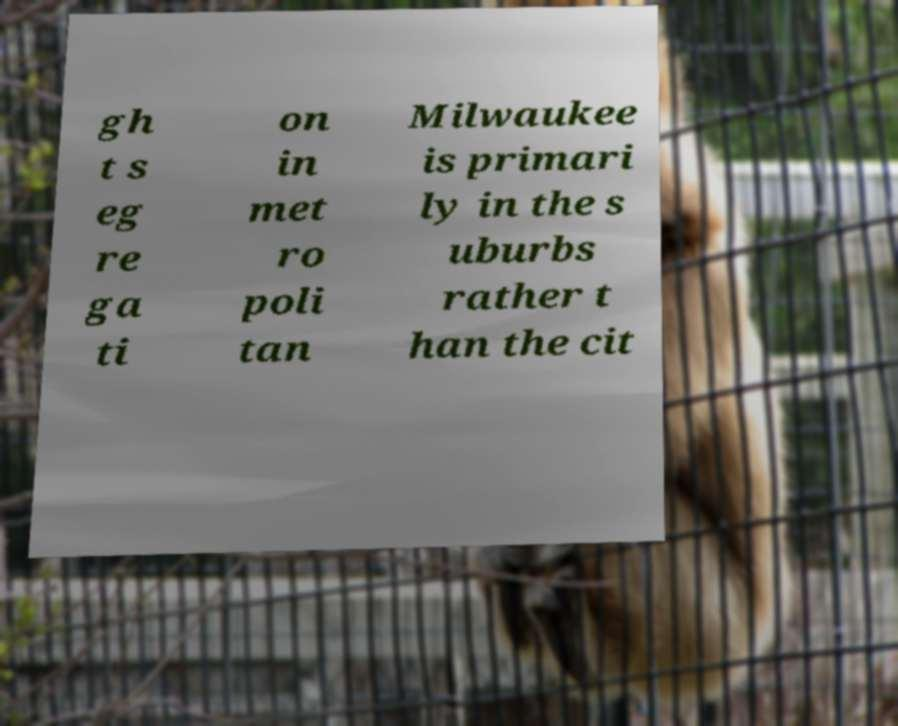For documentation purposes, I need the text within this image transcribed. Could you provide that? gh t s eg re ga ti on in met ro poli tan Milwaukee is primari ly in the s uburbs rather t han the cit 